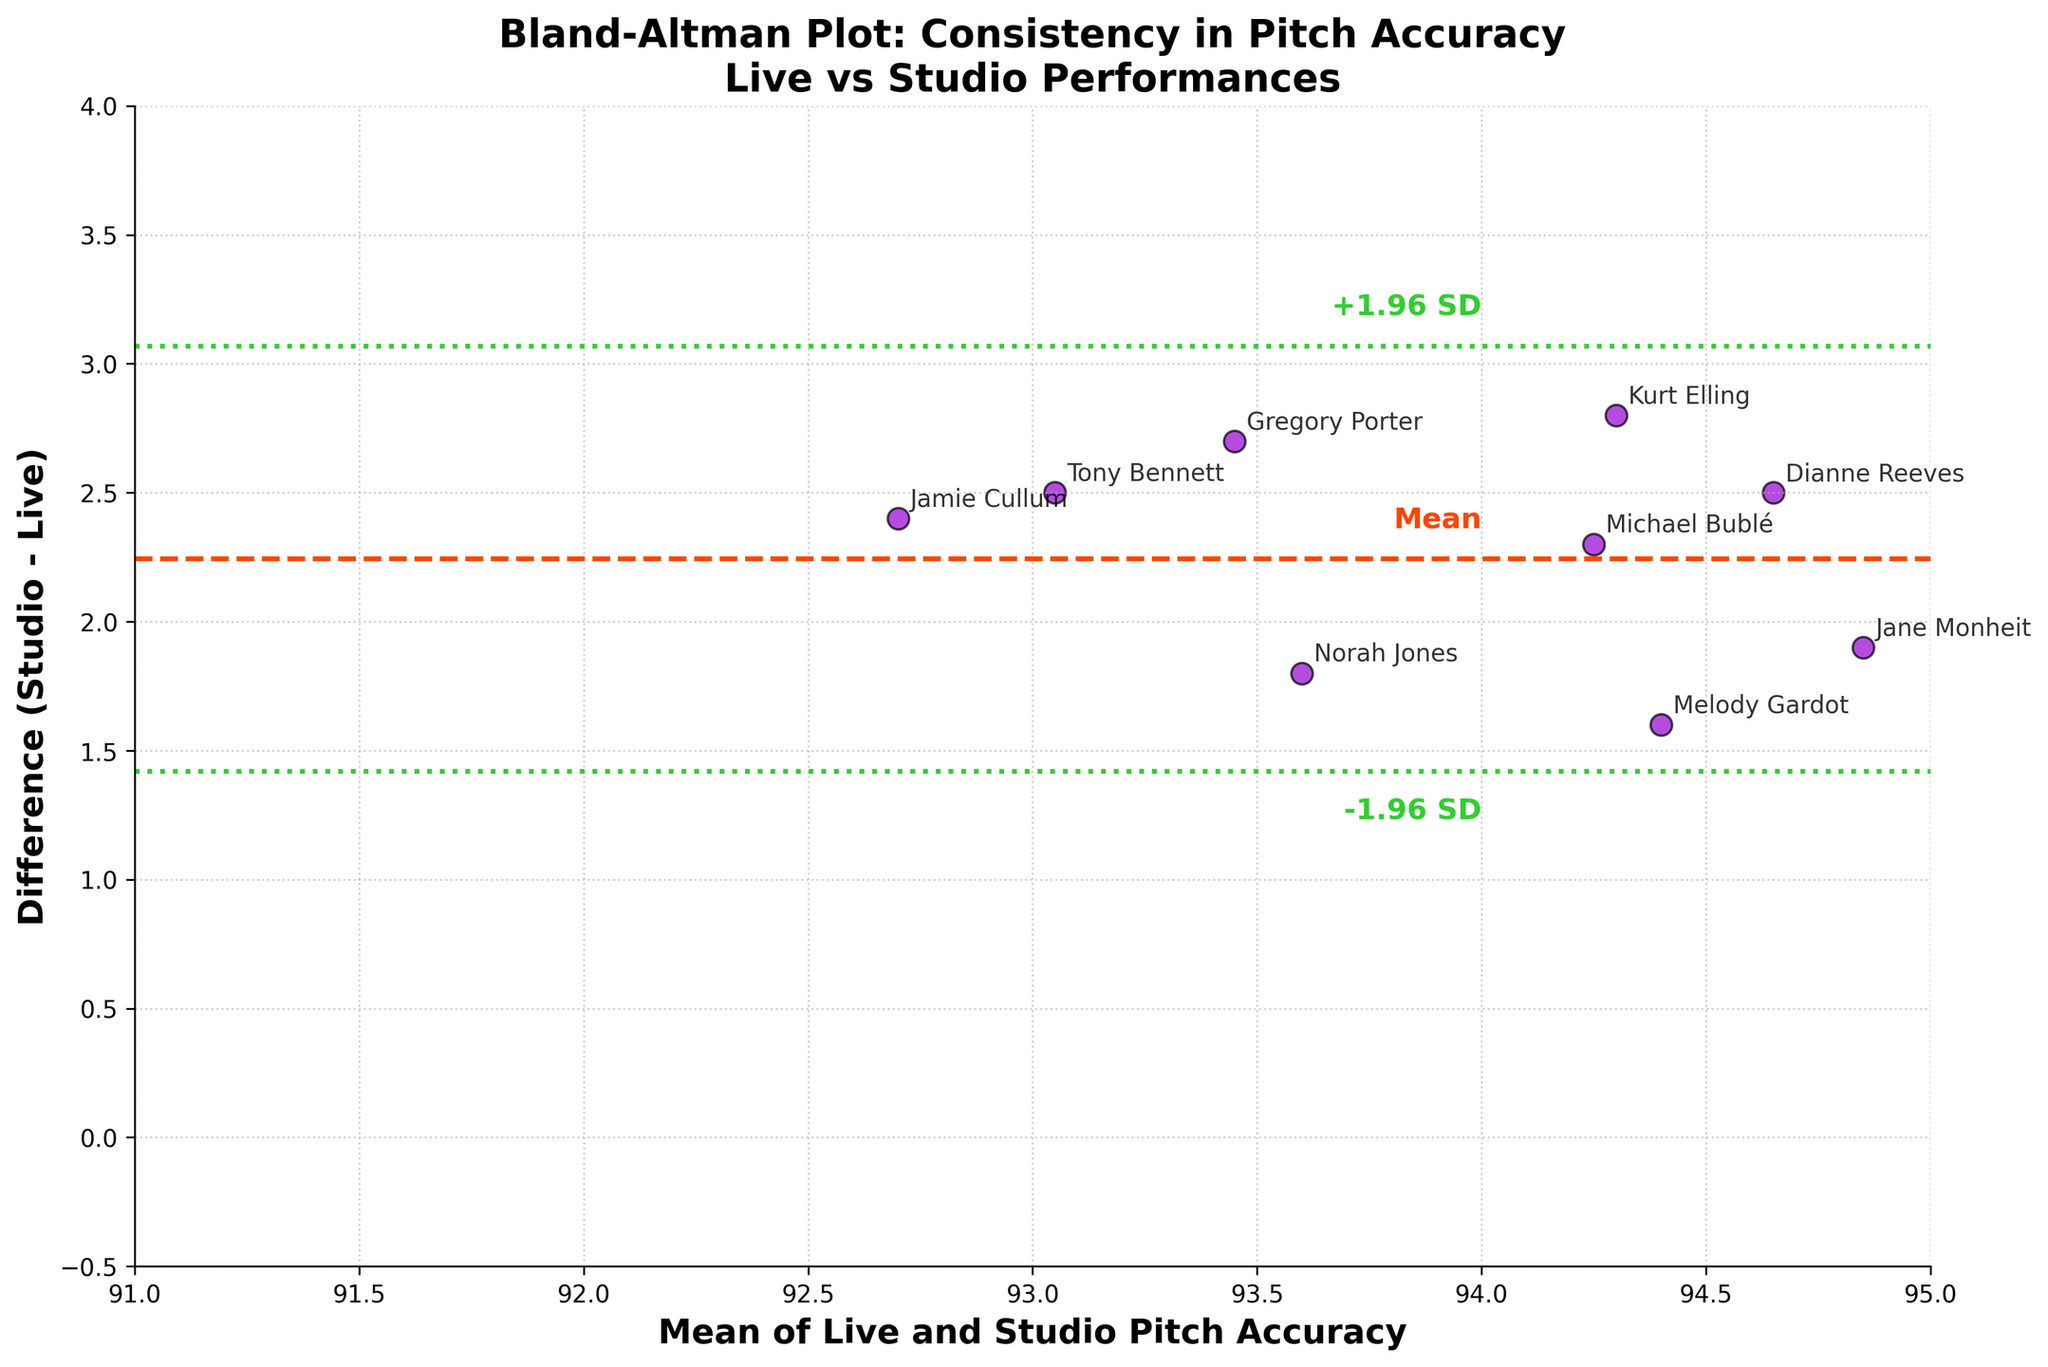Which axis represents the mean of live and studio pitch accuracy? The x-axis represents the "Mean of Live and Studio Pitch Accuracy" as indicated by the label on the axis.
Answer: x-axis What is the mean difference between studio and live pitch accuracy? The mean difference is represented by the dashed horizontal line on the plot, which is labeled "Mean" and positioned around the 1.6 mark on the y-axis.
Answer: 1.6 How many vocalists are within the ±1.96 SD range from the mean difference? By counting the number of scatter points within the green dotted lines (±1.96 SD), you can determine how many vocalists fall within this range. All the points are within this range.
Answer: 14 Which jazz vocalist has the greatest difference between studio and live pitch accuracy? The vocalist with the highest scatter point, which corresponds to the greatest difference, is observed at the highest position on the y-axis. Based on the annotation, this vocalist is Kurt Elling.
Answer: Kurt Elling What is the upper limit of the 95% confidence interval for the differences? The upper limit of the 95% confidence interval is indicated by the top green dotted line on the y-axis, which is labeled as '+1.96 SD'. This line appears to be approximately around the 3.8 mark on the y-axis.
Answer: ~3.8 Compare the pitch accuracy differences of Jamie Cullum and Jane Monheit. Who has a higher difference, and by how much? Jamie Cullum and Jane Monheit are annotated on the scatter plot. By comparing the y-axis values of their points, we see that Jamie Cullum's difference is around 2.4 while Jane Monheit's is about 1.9. The difference in their differences is approximately 0.5.
Answer: Jamie Cullum by 0.5 Is there any vocalist whose pitch accuracy in live performances is better than in studio recordings? To find this, look for any negative values on the y-axis indicating a negative difference (studio - live). There are no points below the zero mark on the y-axis, indicating pitch accuracy in the studio is always better than live for the vocalists.
Answer: No How consistent is the pitch accuracy between live and studio recordings, based on the Bland-Altman plot? Consistency can be evaluated by the spread of the points around the mean difference. The points are fairly close to the mean difference, and all fall within the ±1.96 SD range, indicating a high consistency in pitch accuracy between live and studio recordings.
Answer: High consistency 